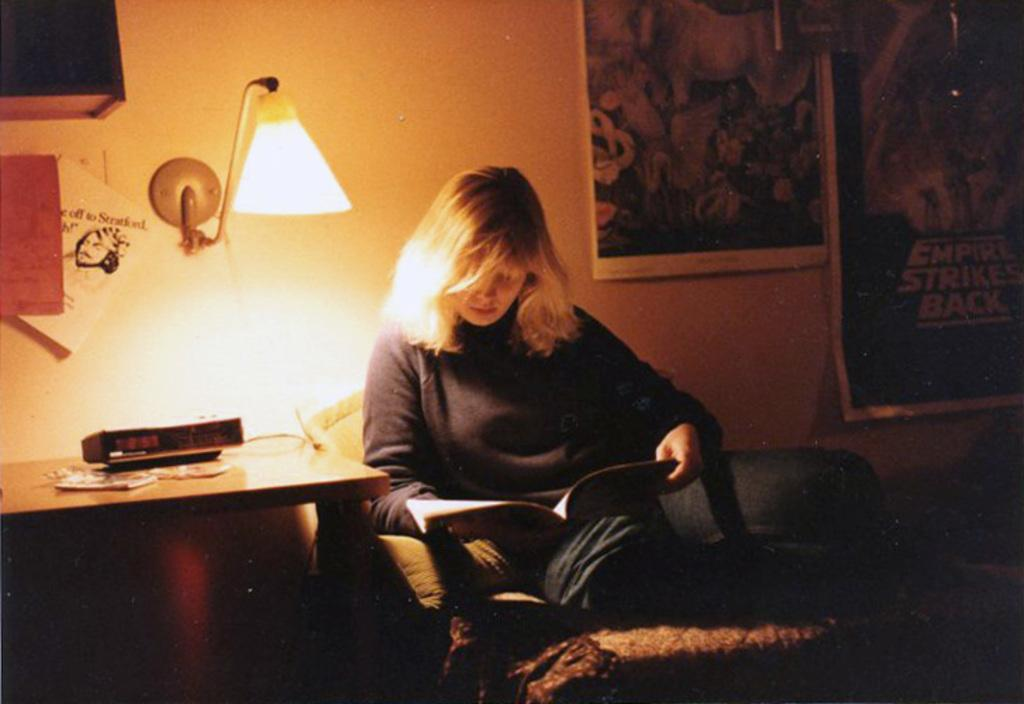Who is the main subject in the image? There is a woman in the image. What is the woman doing in the image? The woman is reading a book. What object is providing light for the woman in the image? There is a lamp on the woman's left side. What can be seen on the wall in the image? There are posters on the wall. Where is the woman's father sitting in the image? There is no father present in the image. What type of throne is the woman sitting on in the image? There is no throne present in the image; the woman is sitting on a chair or a sofa. 